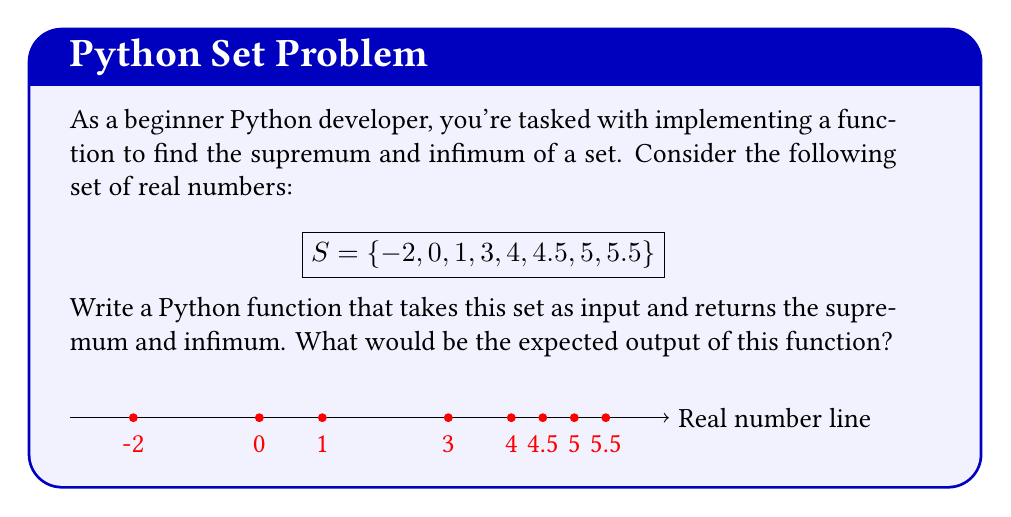What is the answer to this math problem? To find the supremum and infimum of the given set, we need to understand these concepts:

1. Supremum: The least upper bound of a set. It's the smallest number that is greater than or equal to all elements in the set.
2. Infimum: The greatest lower bound of a set. It's the largest number that is less than or equal to all elements in the set.

For the given set $S = \{-2, 0, 1, 3, 4, 4.5, 5, 5.5\}$:

1. To find the supremum:
   - Identify the largest element: 5.5
   - Since 5.5 is in the set, it is the supremum

2. To find the infimum:
   - Identify the smallest element: -2
   - Since -2 is in the set, it is the infimum

In Python, you could implement this function as follows:

```python
def find_sup_inf(s):
    return max(s), min(s)
```

This function uses the built-in `max()` and `min()` functions, which return the maximum and minimum values of an iterable, respectively. For finite sets of real numbers, these correspond to the supremum and infimum.

The expected output of this function for the given set would be a tuple containing the supremum and infimum: (5.5, -2).
Answer: (5.5, -2) 